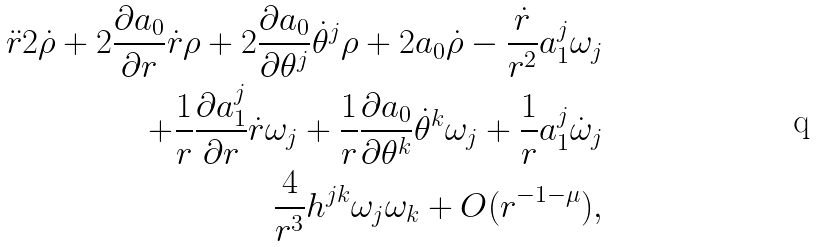<formula> <loc_0><loc_0><loc_500><loc_500>\ddot { r } 2 \dot { \rho } + 2 \frac { \partial a _ { 0 } } { \partial r } \dot { r } \rho + 2 \frac { \partial a _ { 0 } } { \partial \theta ^ { j } } \dot { \theta } ^ { j } \rho + 2 a _ { 0 } \dot { \rho } - \frac { \dot { r } } { r ^ { 2 } } a _ { 1 } ^ { j } \omega _ { j } \\ + \frac { 1 } { r } \frac { \partial a _ { 1 } ^ { j } } { \partial r } \dot { r } \omega _ { j } + \frac { 1 } { r } \frac { \partial a _ { 0 } } { \partial \theta ^ { k } } \dot { \theta } ^ { k } \omega _ { j } + \frac { 1 } { r } a _ { 1 } ^ { j } \dot { \omega } _ { j } \\ \frac { 4 } { r ^ { 3 } } h ^ { j k } \omega _ { j } \omega _ { k } + O ( r ^ { - 1 - \mu } ) ,</formula> 